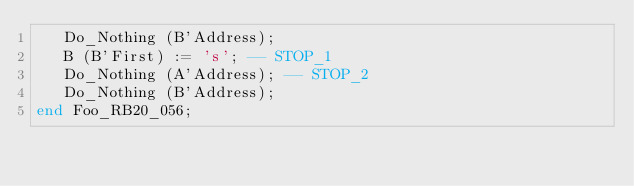<code> <loc_0><loc_0><loc_500><loc_500><_Ada_>   Do_Nothing (B'Address);
   B (B'First) := 's'; -- STOP_1
   Do_Nothing (A'Address); -- STOP_2
   Do_Nothing (B'Address);
end Foo_RB20_056;
</code> 